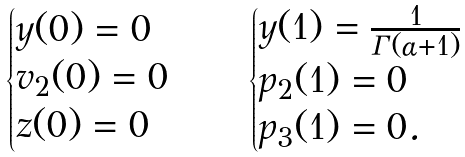Convert formula to latex. <formula><loc_0><loc_0><loc_500><loc_500>\begin{cases} y ( 0 ) = 0 \\ v _ { 2 } ( 0 ) = 0 \\ z ( 0 ) = 0 \end{cases} \quad \begin{cases} y ( 1 ) = \frac { 1 } { \Gamma ( \alpha + 1 ) } \\ p _ { 2 } ( 1 ) = 0 \\ p _ { 3 } ( 1 ) = 0 . \end{cases}</formula> 